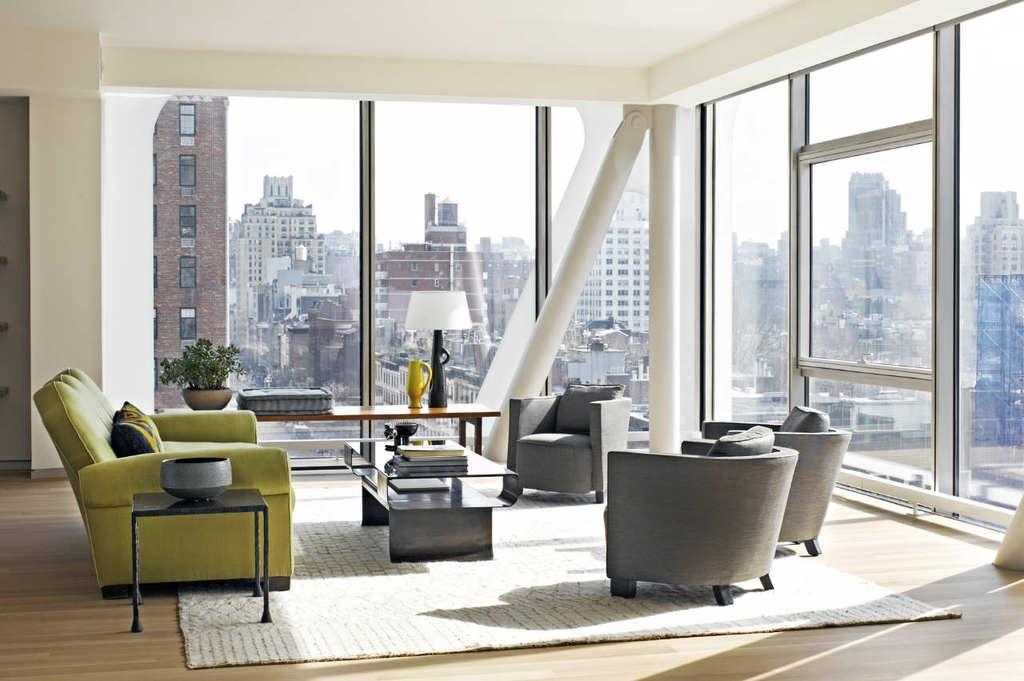Please provide a concise description of this image. In the image we can see sofa and a table on which books are kept. This is a window and we can see many buildings around. 